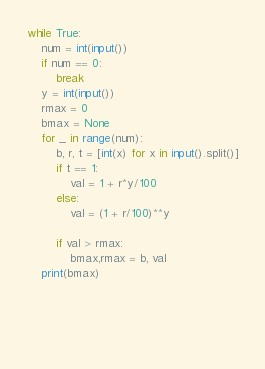Convert code to text. <code><loc_0><loc_0><loc_500><loc_500><_Python_>while True:
    num = int(input())
    if num == 0:
        break
    y = int(input())
    rmax = 0
    bmax = None
    for _ in range(num):
        b, r, t = [int(x) for x in input().split()]
        if t == 1:
            val = 1 + r*y/100
        else:
            val = (1 + r/100)**y
        
        if val > rmax:
            bmax,rmax = b, val
    print(bmax)

        
        
        
</code> 